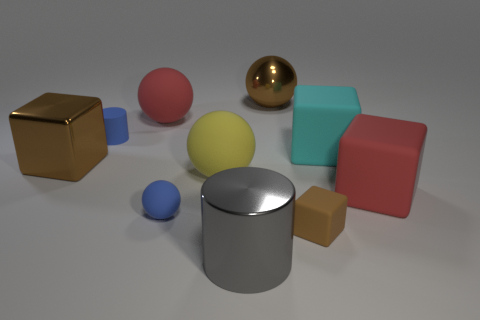Subtract all tiny blocks. How many blocks are left? 3 Subtract 1 cylinders. How many cylinders are left? 1 Add 8 tiny balls. How many tiny balls exist? 9 Subtract all cyan cubes. How many cubes are left? 3 Subtract 1 red blocks. How many objects are left? 9 Subtract all cylinders. How many objects are left? 8 Subtract all yellow spheres. Subtract all blue cubes. How many spheres are left? 3 Subtract all red cylinders. How many brown cubes are left? 2 Subtract all big cylinders. Subtract all big gray things. How many objects are left? 8 Add 5 matte cubes. How many matte cubes are left? 8 